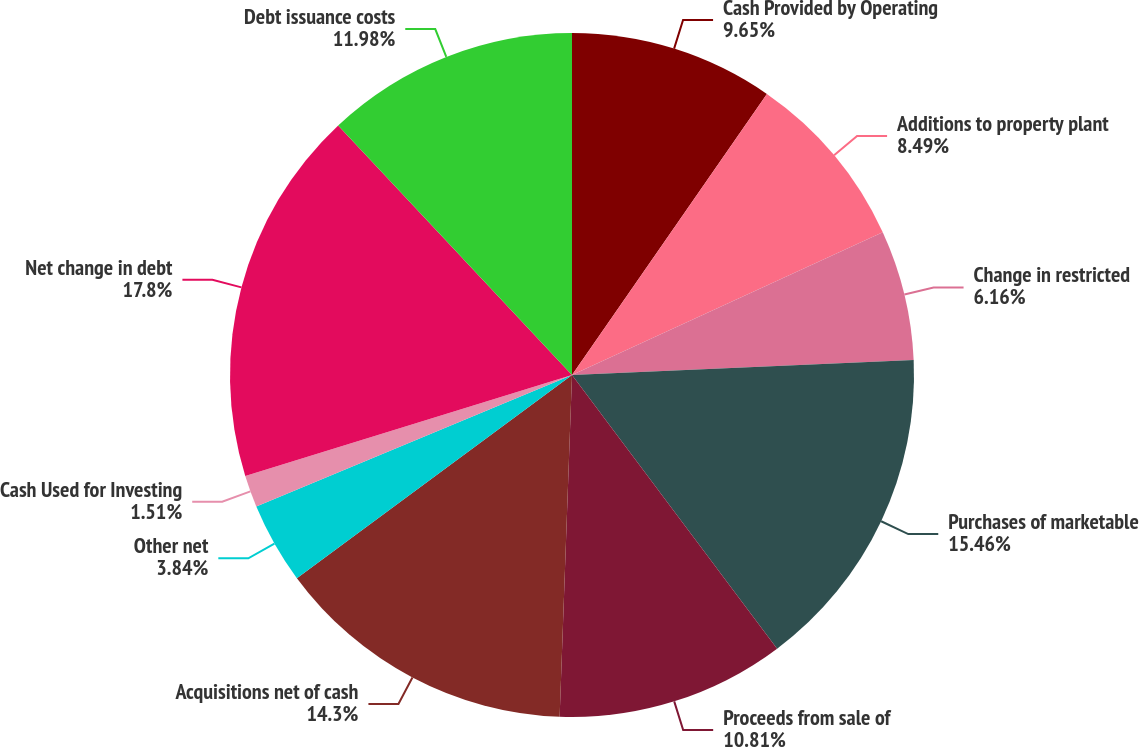Convert chart. <chart><loc_0><loc_0><loc_500><loc_500><pie_chart><fcel>Cash Provided by Operating<fcel>Additions to property plant<fcel>Change in restricted<fcel>Purchases of marketable<fcel>Proceeds from sale of<fcel>Acquisitions net of cash<fcel>Other net<fcel>Cash Used for Investing<fcel>Net change in debt<fcel>Debt issuance costs<nl><fcel>9.65%<fcel>8.49%<fcel>6.16%<fcel>15.46%<fcel>10.81%<fcel>14.3%<fcel>3.84%<fcel>1.51%<fcel>17.79%<fcel>11.98%<nl></chart> 